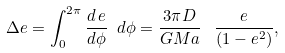<formula> <loc_0><loc_0><loc_500><loc_500>\Delta e = \int _ { 0 } ^ { 2 \pi } \frac { d \, e } { d \phi } \ d \phi = \frac { 3 \pi D } { G M a } \ \, \frac { e } { ( 1 - e ^ { 2 } ) } ,</formula> 